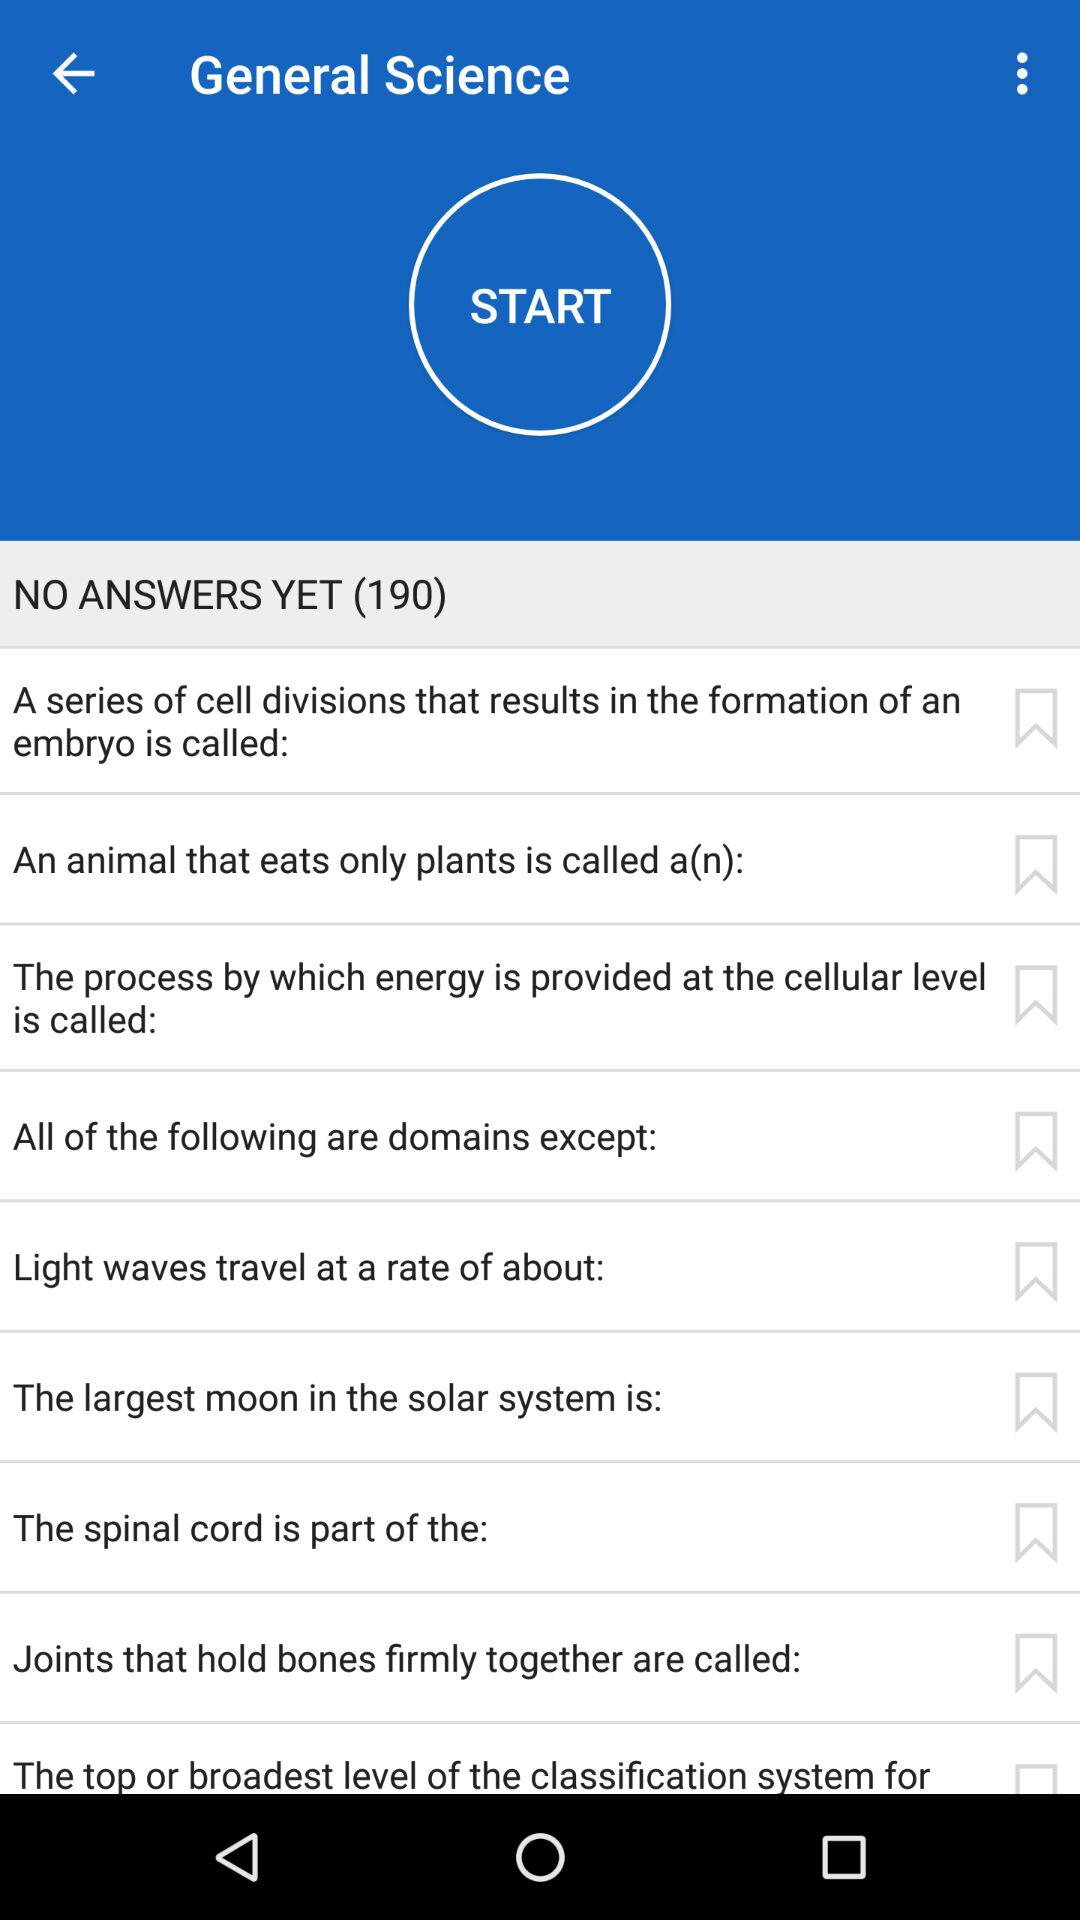How many questions in total are there to answer? There are a total of 190 questions to answer. 